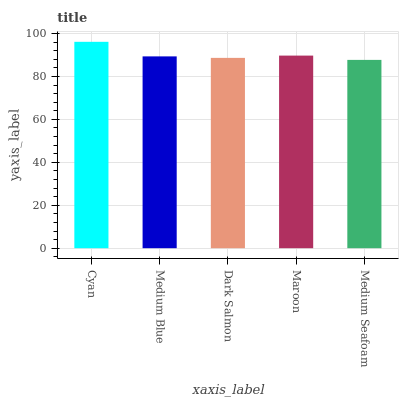Is Medium Seafoam the minimum?
Answer yes or no. Yes. Is Cyan the maximum?
Answer yes or no. Yes. Is Medium Blue the minimum?
Answer yes or no. No. Is Medium Blue the maximum?
Answer yes or no. No. Is Cyan greater than Medium Blue?
Answer yes or no. Yes. Is Medium Blue less than Cyan?
Answer yes or no. Yes. Is Medium Blue greater than Cyan?
Answer yes or no. No. Is Cyan less than Medium Blue?
Answer yes or no. No. Is Medium Blue the high median?
Answer yes or no. Yes. Is Medium Blue the low median?
Answer yes or no. Yes. Is Cyan the high median?
Answer yes or no. No. Is Cyan the low median?
Answer yes or no. No. 